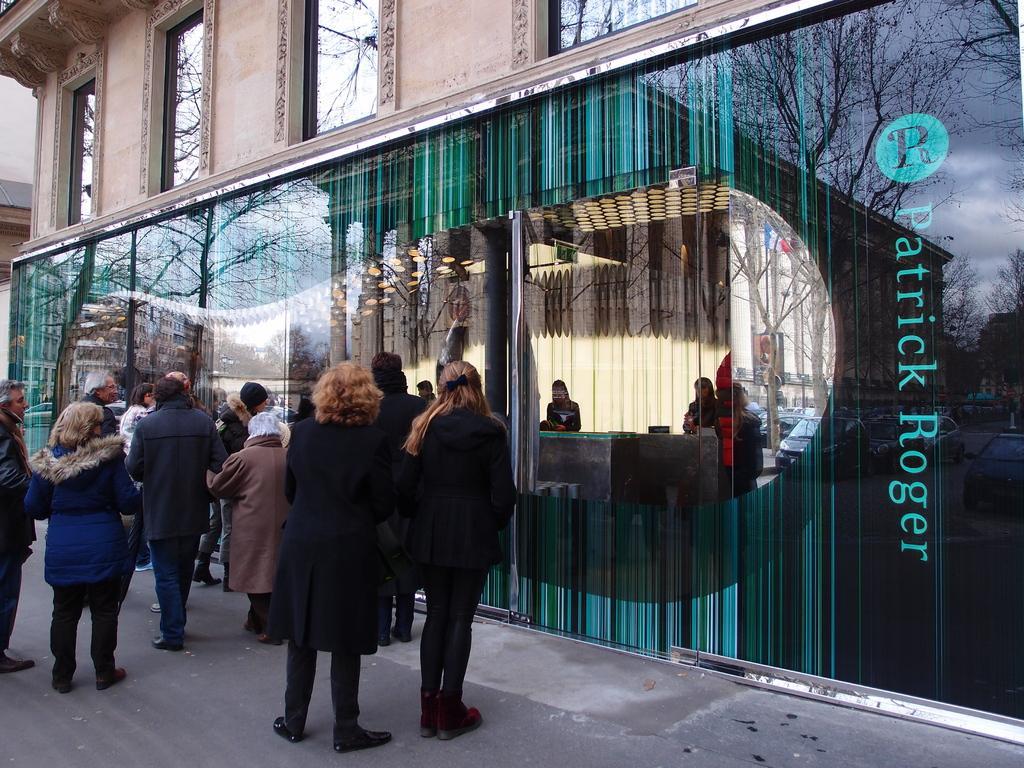Can you describe this image briefly? In this image we can see a building with windows and some text written on it. We can also see some people standing on the road. 